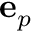Convert formula to latex. <formula><loc_0><loc_0><loc_500><loc_500>e _ { p }</formula> 